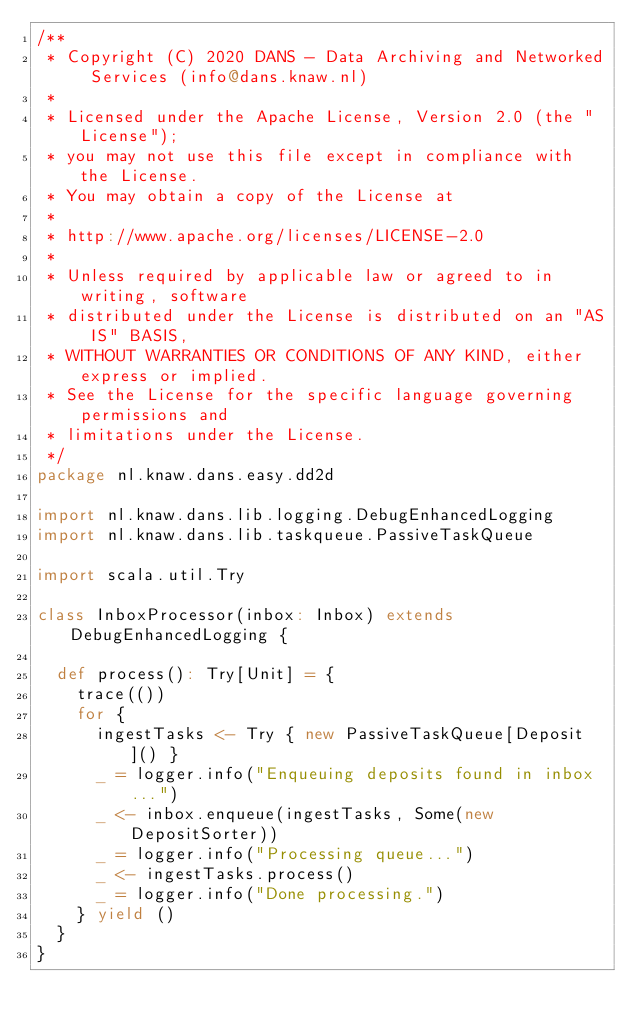<code> <loc_0><loc_0><loc_500><loc_500><_Scala_>/**
 * Copyright (C) 2020 DANS - Data Archiving and Networked Services (info@dans.knaw.nl)
 *
 * Licensed under the Apache License, Version 2.0 (the "License");
 * you may not use this file except in compliance with the License.
 * You may obtain a copy of the License at
 *
 * http://www.apache.org/licenses/LICENSE-2.0
 *
 * Unless required by applicable law or agreed to in writing, software
 * distributed under the License is distributed on an "AS IS" BASIS,
 * WITHOUT WARRANTIES OR CONDITIONS OF ANY KIND, either express or implied.
 * See the License for the specific language governing permissions and
 * limitations under the License.
 */
package nl.knaw.dans.easy.dd2d

import nl.knaw.dans.lib.logging.DebugEnhancedLogging
import nl.knaw.dans.lib.taskqueue.PassiveTaskQueue

import scala.util.Try

class InboxProcessor(inbox: Inbox) extends DebugEnhancedLogging {

  def process(): Try[Unit] = {
    trace(())
    for {
      ingestTasks <- Try { new PassiveTaskQueue[Deposit]() }
      _ = logger.info("Enqueuing deposits found in inbox...")
      _ <- inbox.enqueue(ingestTasks, Some(new DepositSorter))
      _ = logger.info("Processing queue...")
      _ <- ingestTasks.process()
      _ = logger.info("Done processing.")
    } yield ()
  }
}
</code> 